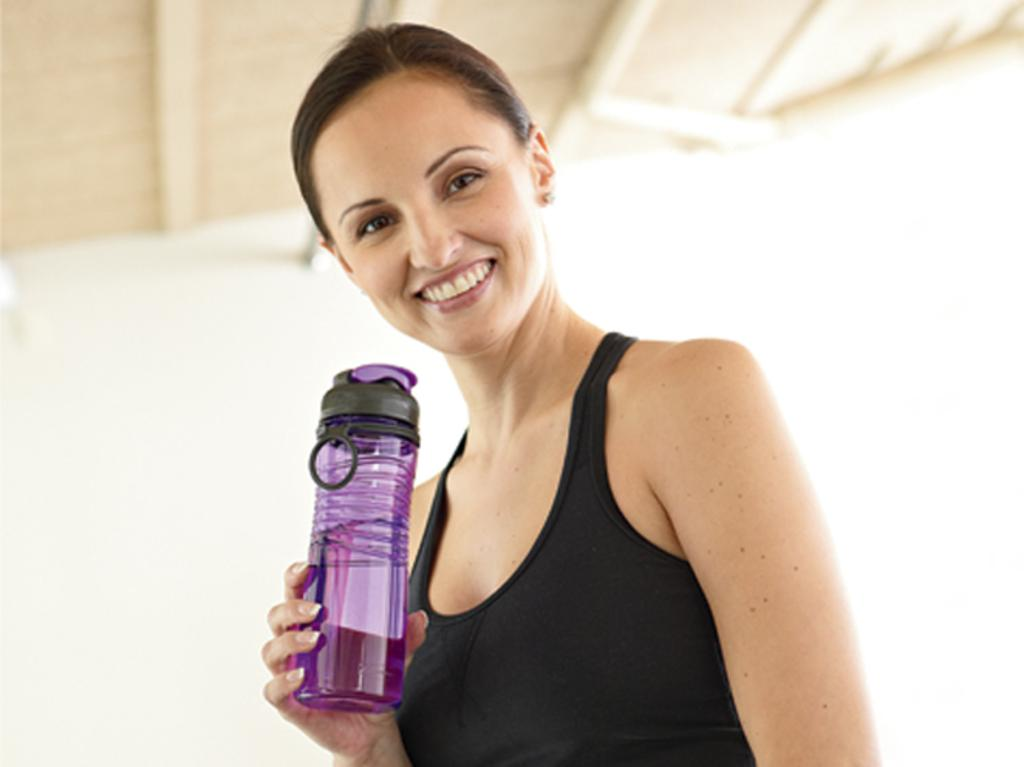Who is present in the image? There is a woman in the image. What color is the woman wearing? The woman is wearing black. What object is the woman holding in the image? The woman is holding a water bottle. What can be seen in the background of the image? There is a cream-colored roof visible in the background of the image. What type of beetle can be seen crawling on the woman's shoulder in the image? There is no beetle present on the woman's shoulder in the image. What order of insects might the beetle belong to if it were present in the image? Since there is no beetle present in the image, it is not possible to determine the order of insects it might belong to. 